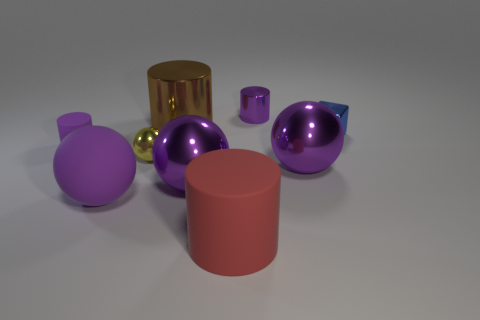What is the texture of the matte objects, and how are they distributed in the image? The matte objects in the image, which are the yellow cylinder and the pink cylinder, have a non-reflective surface that diffuses light, providing a soft contrast to the metal objects. The yellow cylinder is located to the right of the gold cylinder, while the pink cylinder is off to the left side, standing on its own. Is there any object that appears to be partially obscured from view? Indeed, there is a small blue object that is partially obscured by a large purple sphere. This creates a sense of depth and layering within the composition of the image. 